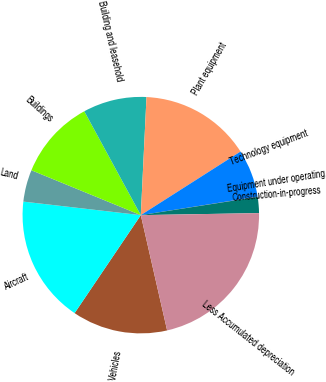Convert chart. <chart><loc_0><loc_0><loc_500><loc_500><pie_chart><fcel>Vehicles<fcel>Aircraft<fcel>Land<fcel>Buildings<fcel>Building and leasehold<fcel>Plant equipment<fcel>Technology equipment<fcel>Equipment under operating<fcel>Construction-in-progress<fcel>Less Accumulated depreciation<nl><fcel>13.03%<fcel>17.37%<fcel>4.37%<fcel>10.87%<fcel>8.7%<fcel>15.2%<fcel>6.53%<fcel>0.03%<fcel>2.2%<fcel>21.7%<nl></chart> 